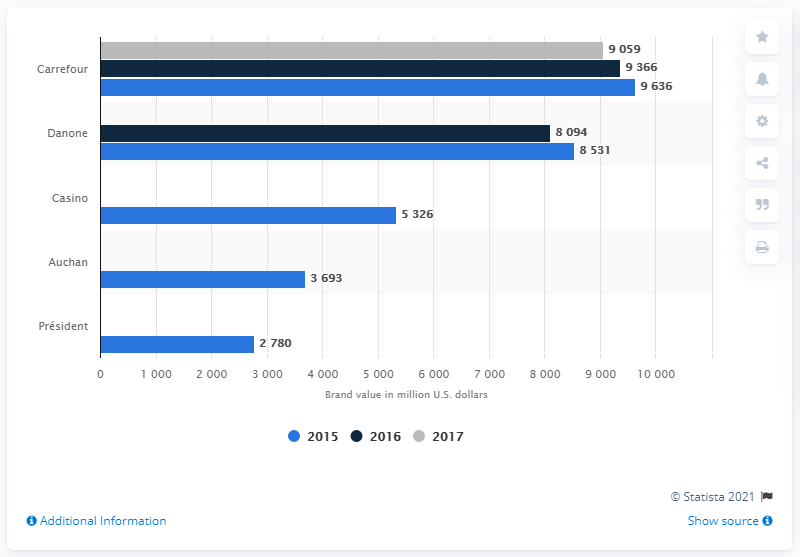Highlight a few significant elements in this photo. In 2015, Carrefour's brand value was estimated to be 9,636 US dollars. According to the information available in 2015, Danone was the second most valuable French food brand. 